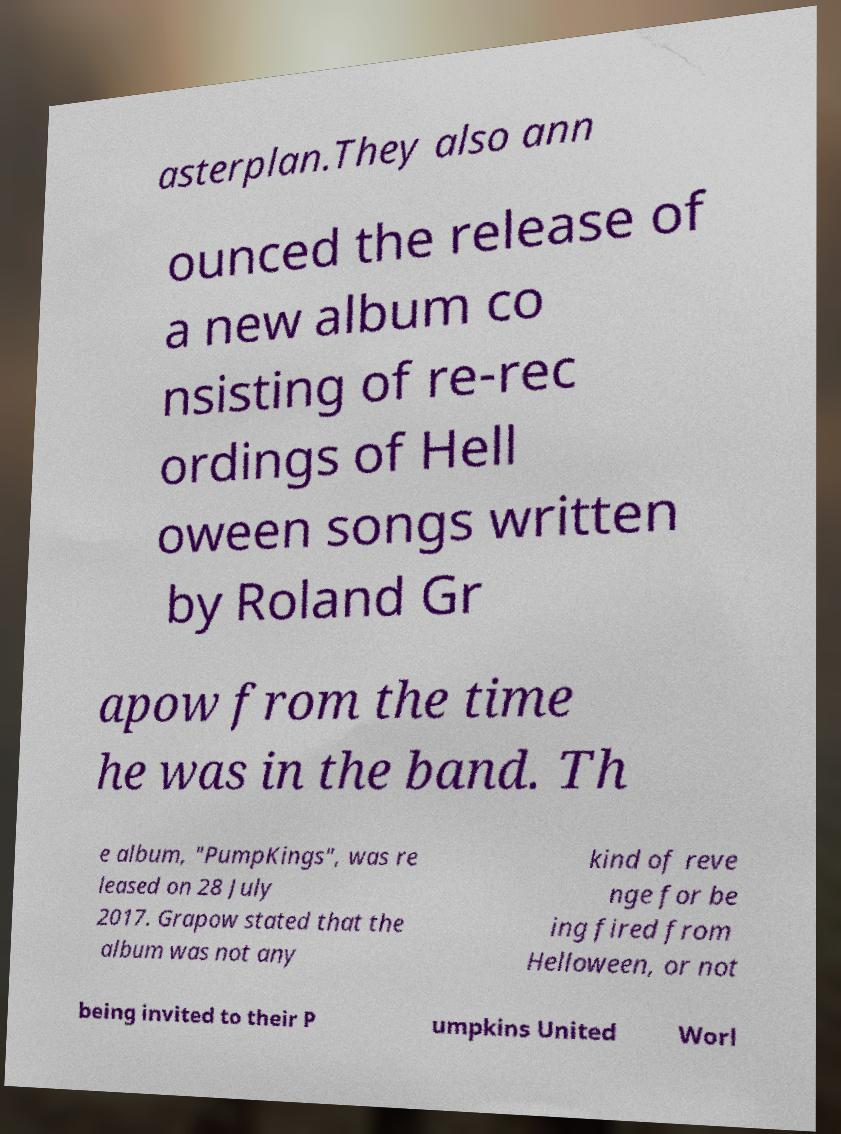Can you accurately transcribe the text from the provided image for me? asterplan.They also ann ounced the release of a new album co nsisting of re-rec ordings of Hell oween songs written by Roland Gr apow from the time he was in the band. Th e album, "PumpKings", was re leased on 28 July 2017. Grapow stated that the album was not any kind of reve nge for be ing fired from Helloween, or not being invited to their P umpkins United Worl 